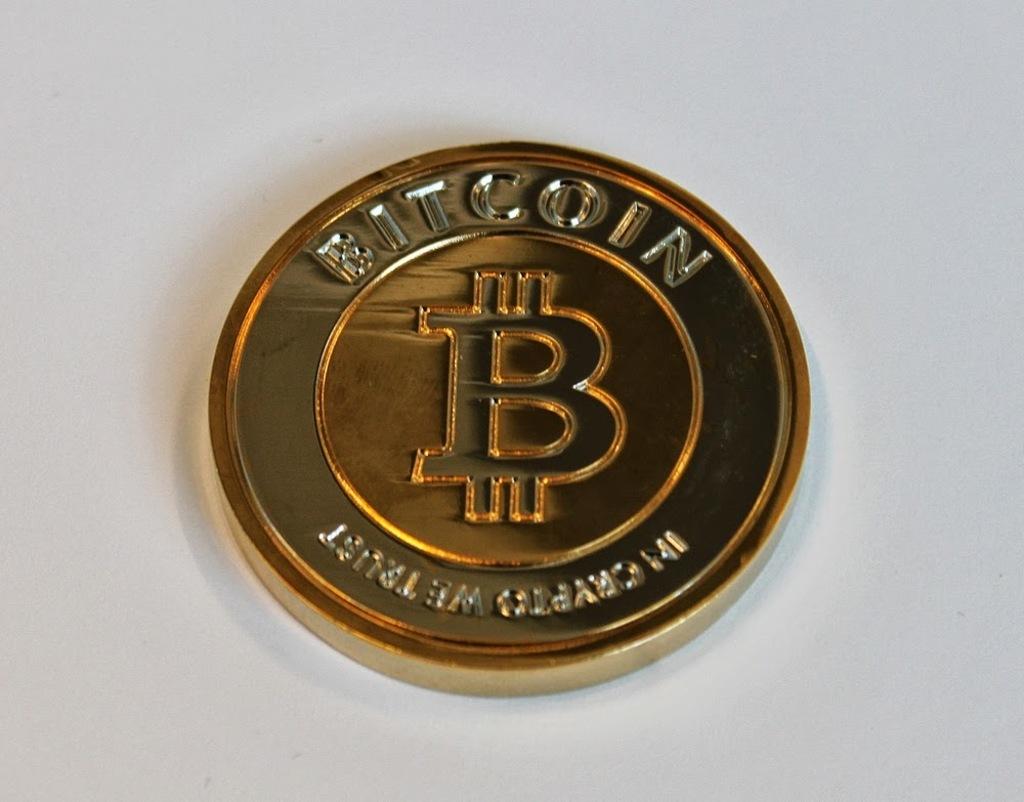What kind of coin is this?
Your answer should be very brief. Bitcoin. What letter is in the middle of the coin?
Offer a terse response. B. 